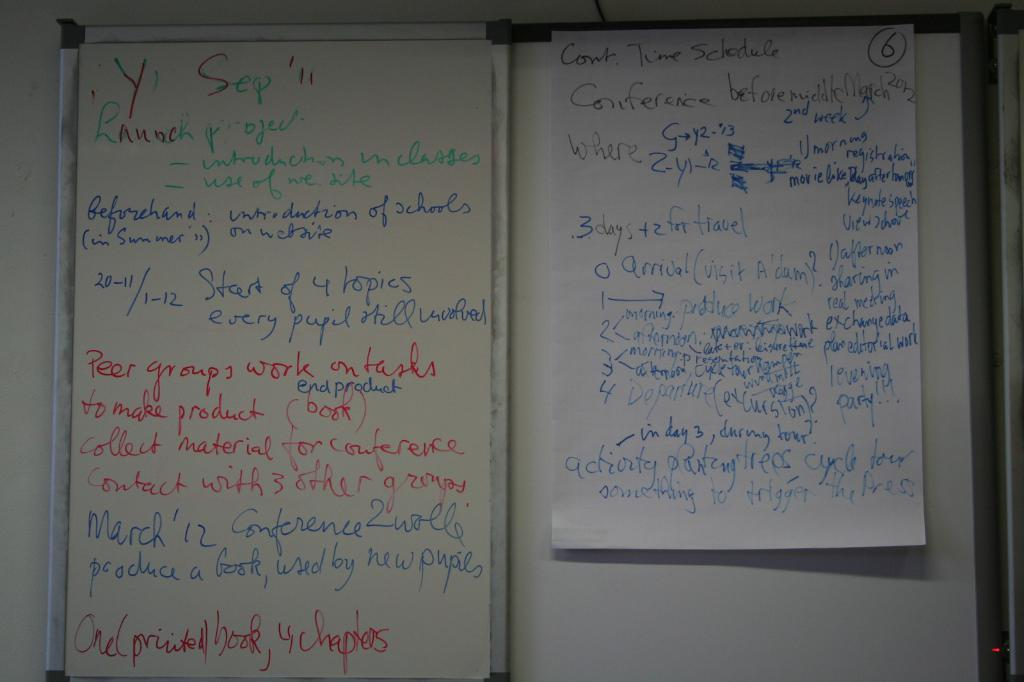<image>
Summarize the visual content of the image. A list of of things that needs to be done starts with launch project. 